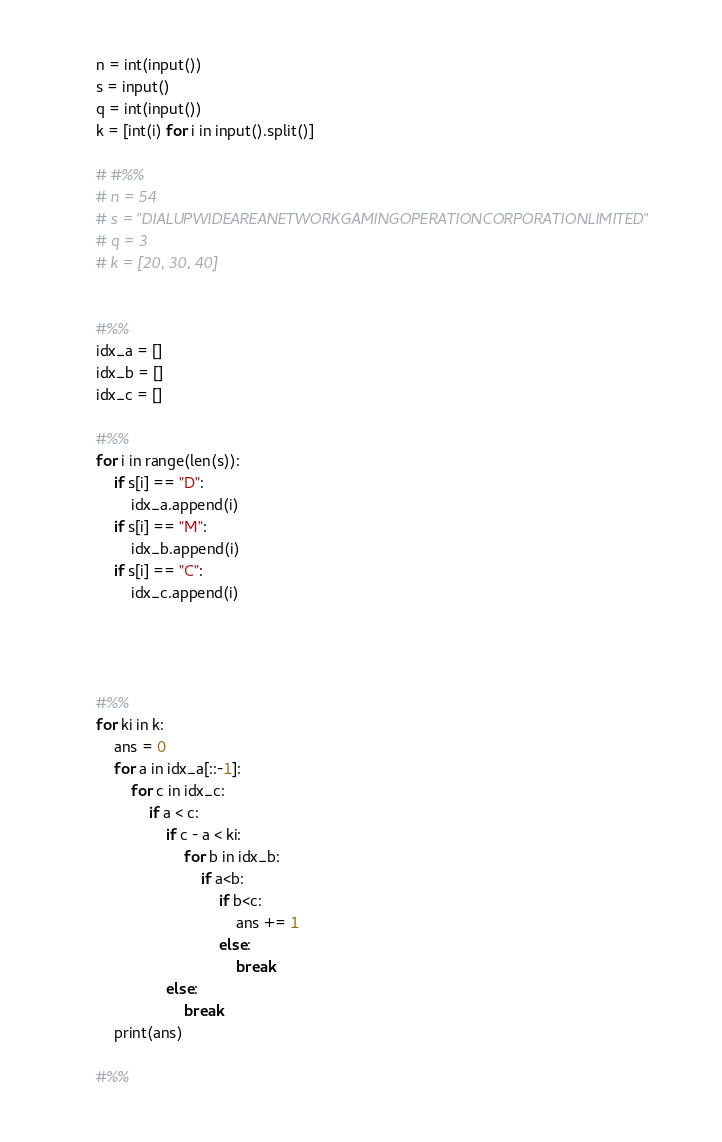Convert code to text. <code><loc_0><loc_0><loc_500><loc_500><_Python_>n = int(input())
s = input()
q = int(input())
k = [int(i) for i in input().split()]

# #%%
# n = 54
# s = "DIALUPWIDEAREANETWORKGAMINGOPERATIONCORPORATIONLIMITED"
# q = 3
# k = [20, 30, 40]


#%%
idx_a = []
idx_b = []
idx_c = []

#%%
for i in range(len(s)):
    if s[i] == "D":
        idx_a.append(i)
    if s[i] == "M":
        idx_b.append(i)
    if s[i] == "C":
        idx_c.append(i)
        



#%%
for ki in k:
    ans = 0
    for a in idx_a[::-1]:
        for c in idx_c:
            if a < c:
                if c - a < ki:
                    for b in idx_b:
                        if a<b:
                            if b<c:
                                ans += 1
                            else:
                                break
                else:
                    break
    print(ans)            

#%%
</code> 